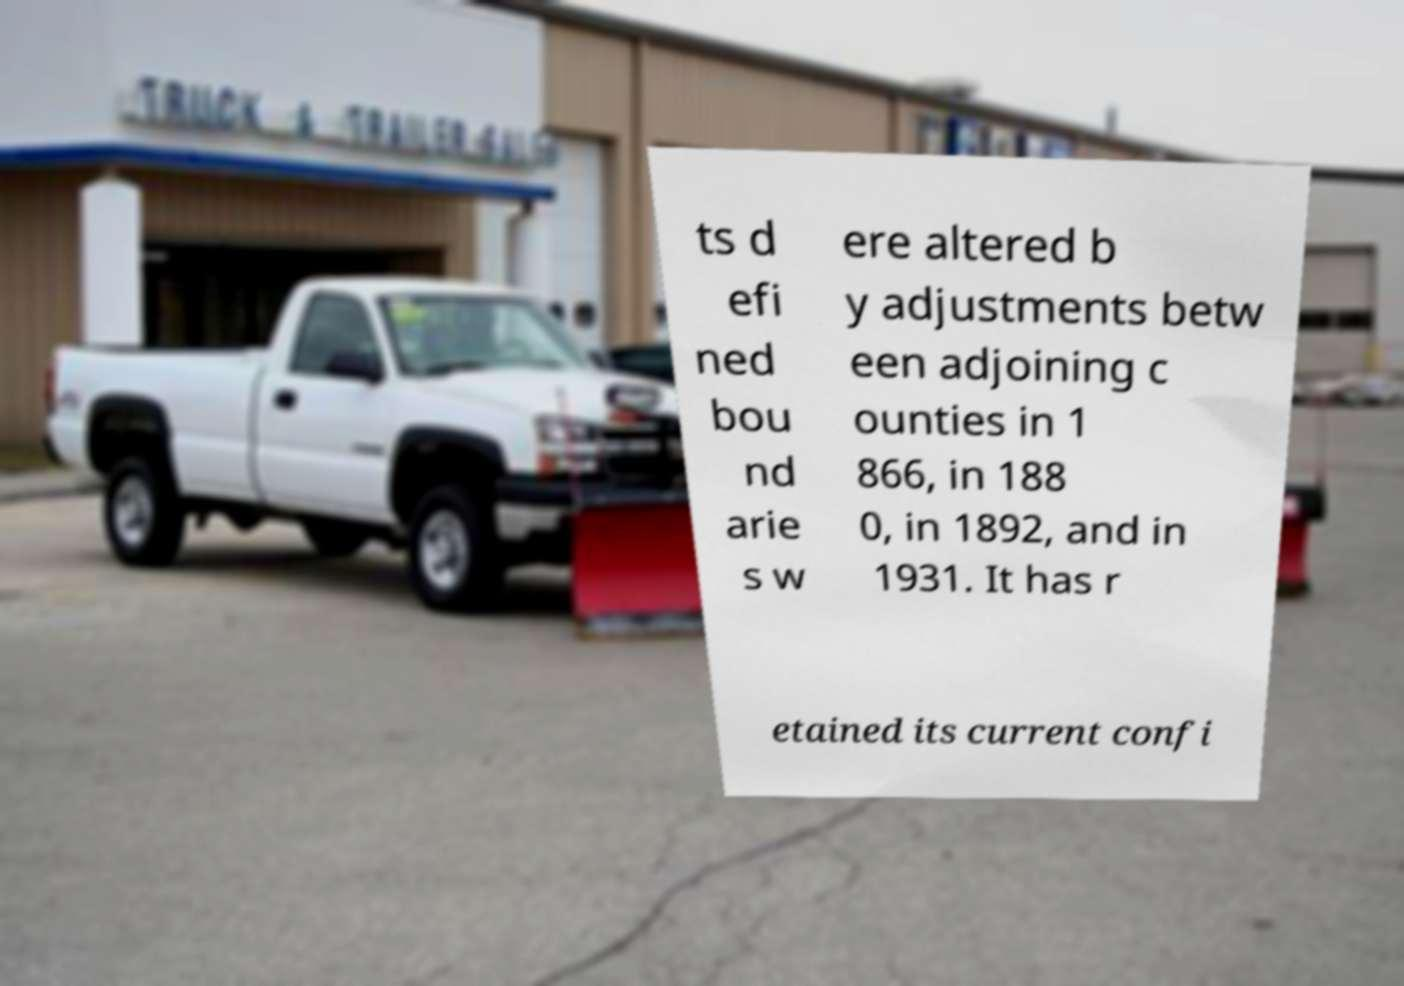I need the written content from this picture converted into text. Can you do that? ts d efi ned bou nd arie s w ere altered b y adjustments betw een adjoining c ounties in 1 866, in 188 0, in 1892, and in 1931. It has r etained its current confi 